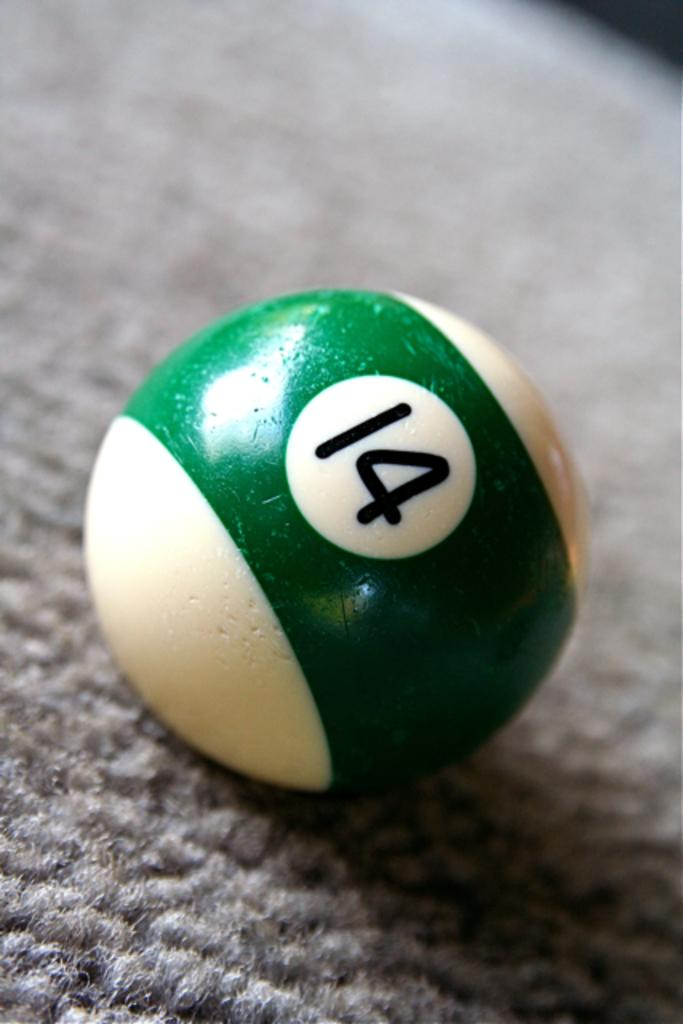<image>
Offer a succinct explanation of the picture presented. A pool ball with a green stripe and 14 on it. 